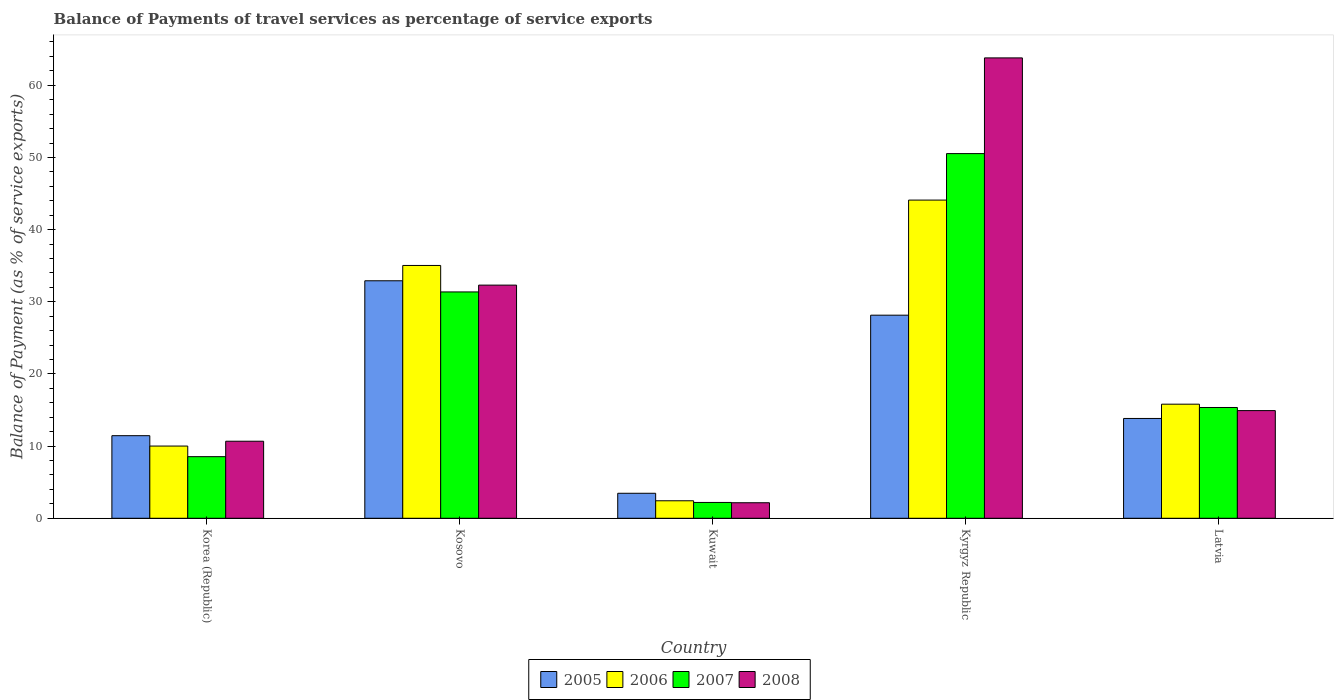How many different coloured bars are there?
Your answer should be compact. 4. How many bars are there on the 1st tick from the left?
Your response must be concise. 4. How many bars are there on the 2nd tick from the right?
Keep it short and to the point. 4. What is the label of the 4th group of bars from the left?
Give a very brief answer. Kyrgyz Republic. What is the balance of payments of travel services in 2005 in Kuwait?
Ensure brevity in your answer.  3.46. Across all countries, what is the maximum balance of payments of travel services in 2005?
Offer a very short reply. 32.91. Across all countries, what is the minimum balance of payments of travel services in 2008?
Give a very brief answer. 2.15. In which country was the balance of payments of travel services in 2007 maximum?
Offer a very short reply. Kyrgyz Republic. In which country was the balance of payments of travel services in 2007 minimum?
Your response must be concise. Kuwait. What is the total balance of payments of travel services in 2007 in the graph?
Offer a very short reply. 107.97. What is the difference between the balance of payments of travel services in 2006 in Korea (Republic) and that in Kuwait?
Offer a very short reply. 7.58. What is the difference between the balance of payments of travel services in 2007 in Kosovo and the balance of payments of travel services in 2005 in Korea (Republic)?
Offer a terse response. 19.92. What is the average balance of payments of travel services in 2007 per country?
Your answer should be compact. 21.59. What is the difference between the balance of payments of travel services of/in 2005 and balance of payments of travel services of/in 2007 in Kuwait?
Your response must be concise. 1.27. In how many countries, is the balance of payments of travel services in 2006 greater than 16 %?
Ensure brevity in your answer.  2. What is the ratio of the balance of payments of travel services in 2007 in Korea (Republic) to that in Latvia?
Ensure brevity in your answer.  0.56. What is the difference between the highest and the second highest balance of payments of travel services in 2005?
Your answer should be very brief. 4.77. What is the difference between the highest and the lowest balance of payments of travel services in 2005?
Ensure brevity in your answer.  29.45. In how many countries, is the balance of payments of travel services in 2006 greater than the average balance of payments of travel services in 2006 taken over all countries?
Your answer should be compact. 2. Is the sum of the balance of payments of travel services in 2007 in Korea (Republic) and Latvia greater than the maximum balance of payments of travel services in 2005 across all countries?
Ensure brevity in your answer.  No. What does the 4th bar from the left in Kuwait represents?
Ensure brevity in your answer.  2008. What does the 1st bar from the right in Kosovo represents?
Your answer should be compact. 2008. Is it the case that in every country, the sum of the balance of payments of travel services in 2005 and balance of payments of travel services in 2008 is greater than the balance of payments of travel services in 2006?
Provide a short and direct response. Yes. How many bars are there?
Your response must be concise. 20. What is the difference between two consecutive major ticks on the Y-axis?
Offer a very short reply. 10. Does the graph contain any zero values?
Offer a very short reply. No. How are the legend labels stacked?
Ensure brevity in your answer.  Horizontal. What is the title of the graph?
Give a very brief answer. Balance of Payments of travel services as percentage of service exports. What is the label or title of the Y-axis?
Ensure brevity in your answer.  Balance of Payment (as % of service exports). What is the Balance of Payment (as % of service exports) of 2005 in Korea (Republic)?
Provide a succinct answer. 11.44. What is the Balance of Payment (as % of service exports) in 2006 in Korea (Republic)?
Give a very brief answer. 10.01. What is the Balance of Payment (as % of service exports) of 2007 in Korea (Republic)?
Provide a short and direct response. 8.54. What is the Balance of Payment (as % of service exports) in 2008 in Korea (Republic)?
Ensure brevity in your answer.  10.68. What is the Balance of Payment (as % of service exports) in 2005 in Kosovo?
Give a very brief answer. 32.91. What is the Balance of Payment (as % of service exports) in 2006 in Kosovo?
Keep it short and to the point. 35.03. What is the Balance of Payment (as % of service exports) in 2007 in Kosovo?
Provide a succinct answer. 31.36. What is the Balance of Payment (as % of service exports) in 2008 in Kosovo?
Offer a terse response. 32.31. What is the Balance of Payment (as % of service exports) in 2005 in Kuwait?
Give a very brief answer. 3.46. What is the Balance of Payment (as % of service exports) of 2006 in Kuwait?
Offer a terse response. 2.42. What is the Balance of Payment (as % of service exports) of 2007 in Kuwait?
Your response must be concise. 2.19. What is the Balance of Payment (as % of service exports) of 2008 in Kuwait?
Make the answer very short. 2.15. What is the Balance of Payment (as % of service exports) in 2005 in Kyrgyz Republic?
Offer a terse response. 28.14. What is the Balance of Payment (as % of service exports) of 2006 in Kyrgyz Republic?
Make the answer very short. 44.09. What is the Balance of Payment (as % of service exports) in 2007 in Kyrgyz Republic?
Your answer should be very brief. 50.53. What is the Balance of Payment (as % of service exports) of 2008 in Kyrgyz Republic?
Keep it short and to the point. 63.79. What is the Balance of Payment (as % of service exports) in 2005 in Latvia?
Make the answer very short. 13.83. What is the Balance of Payment (as % of service exports) of 2006 in Latvia?
Make the answer very short. 15.81. What is the Balance of Payment (as % of service exports) of 2007 in Latvia?
Keep it short and to the point. 15.35. What is the Balance of Payment (as % of service exports) in 2008 in Latvia?
Make the answer very short. 14.92. Across all countries, what is the maximum Balance of Payment (as % of service exports) in 2005?
Keep it short and to the point. 32.91. Across all countries, what is the maximum Balance of Payment (as % of service exports) of 2006?
Give a very brief answer. 44.09. Across all countries, what is the maximum Balance of Payment (as % of service exports) in 2007?
Offer a terse response. 50.53. Across all countries, what is the maximum Balance of Payment (as % of service exports) of 2008?
Your answer should be very brief. 63.79. Across all countries, what is the minimum Balance of Payment (as % of service exports) in 2005?
Offer a terse response. 3.46. Across all countries, what is the minimum Balance of Payment (as % of service exports) in 2006?
Provide a succinct answer. 2.42. Across all countries, what is the minimum Balance of Payment (as % of service exports) of 2007?
Offer a terse response. 2.19. Across all countries, what is the minimum Balance of Payment (as % of service exports) in 2008?
Ensure brevity in your answer.  2.15. What is the total Balance of Payment (as % of service exports) of 2005 in the graph?
Provide a short and direct response. 89.79. What is the total Balance of Payment (as % of service exports) in 2006 in the graph?
Keep it short and to the point. 107.36. What is the total Balance of Payment (as % of service exports) in 2007 in the graph?
Offer a very short reply. 107.97. What is the total Balance of Payment (as % of service exports) of 2008 in the graph?
Ensure brevity in your answer.  123.85. What is the difference between the Balance of Payment (as % of service exports) of 2005 in Korea (Republic) and that in Kosovo?
Make the answer very short. -21.47. What is the difference between the Balance of Payment (as % of service exports) of 2006 in Korea (Republic) and that in Kosovo?
Ensure brevity in your answer.  -25.03. What is the difference between the Balance of Payment (as % of service exports) in 2007 in Korea (Republic) and that in Kosovo?
Ensure brevity in your answer.  -22.83. What is the difference between the Balance of Payment (as % of service exports) in 2008 in Korea (Republic) and that in Kosovo?
Provide a succinct answer. -21.63. What is the difference between the Balance of Payment (as % of service exports) in 2005 in Korea (Republic) and that in Kuwait?
Offer a terse response. 7.98. What is the difference between the Balance of Payment (as % of service exports) of 2006 in Korea (Republic) and that in Kuwait?
Give a very brief answer. 7.58. What is the difference between the Balance of Payment (as % of service exports) in 2007 in Korea (Republic) and that in Kuwait?
Ensure brevity in your answer.  6.34. What is the difference between the Balance of Payment (as % of service exports) in 2008 in Korea (Republic) and that in Kuwait?
Offer a very short reply. 8.52. What is the difference between the Balance of Payment (as % of service exports) in 2005 in Korea (Republic) and that in Kyrgyz Republic?
Ensure brevity in your answer.  -16.7. What is the difference between the Balance of Payment (as % of service exports) of 2006 in Korea (Republic) and that in Kyrgyz Republic?
Provide a short and direct response. -34.08. What is the difference between the Balance of Payment (as % of service exports) of 2007 in Korea (Republic) and that in Kyrgyz Republic?
Ensure brevity in your answer.  -41.99. What is the difference between the Balance of Payment (as % of service exports) in 2008 in Korea (Republic) and that in Kyrgyz Republic?
Offer a terse response. -53.12. What is the difference between the Balance of Payment (as % of service exports) of 2005 in Korea (Republic) and that in Latvia?
Your answer should be very brief. -2.39. What is the difference between the Balance of Payment (as % of service exports) of 2006 in Korea (Republic) and that in Latvia?
Offer a terse response. -5.8. What is the difference between the Balance of Payment (as % of service exports) in 2007 in Korea (Republic) and that in Latvia?
Offer a terse response. -6.81. What is the difference between the Balance of Payment (as % of service exports) in 2008 in Korea (Republic) and that in Latvia?
Provide a short and direct response. -4.24. What is the difference between the Balance of Payment (as % of service exports) of 2005 in Kosovo and that in Kuwait?
Give a very brief answer. 29.45. What is the difference between the Balance of Payment (as % of service exports) of 2006 in Kosovo and that in Kuwait?
Your answer should be compact. 32.61. What is the difference between the Balance of Payment (as % of service exports) in 2007 in Kosovo and that in Kuwait?
Give a very brief answer. 29.17. What is the difference between the Balance of Payment (as % of service exports) of 2008 in Kosovo and that in Kuwait?
Keep it short and to the point. 30.16. What is the difference between the Balance of Payment (as % of service exports) in 2005 in Kosovo and that in Kyrgyz Republic?
Offer a terse response. 4.77. What is the difference between the Balance of Payment (as % of service exports) in 2006 in Kosovo and that in Kyrgyz Republic?
Provide a short and direct response. -9.06. What is the difference between the Balance of Payment (as % of service exports) in 2007 in Kosovo and that in Kyrgyz Republic?
Make the answer very short. -19.17. What is the difference between the Balance of Payment (as % of service exports) of 2008 in Kosovo and that in Kyrgyz Republic?
Keep it short and to the point. -31.49. What is the difference between the Balance of Payment (as % of service exports) of 2005 in Kosovo and that in Latvia?
Give a very brief answer. 19.08. What is the difference between the Balance of Payment (as % of service exports) of 2006 in Kosovo and that in Latvia?
Your response must be concise. 19.22. What is the difference between the Balance of Payment (as % of service exports) of 2007 in Kosovo and that in Latvia?
Offer a very short reply. 16.01. What is the difference between the Balance of Payment (as % of service exports) in 2008 in Kosovo and that in Latvia?
Your response must be concise. 17.39. What is the difference between the Balance of Payment (as % of service exports) of 2005 in Kuwait and that in Kyrgyz Republic?
Your answer should be very brief. -24.68. What is the difference between the Balance of Payment (as % of service exports) of 2006 in Kuwait and that in Kyrgyz Republic?
Your answer should be compact. -41.67. What is the difference between the Balance of Payment (as % of service exports) of 2007 in Kuwait and that in Kyrgyz Republic?
Your answer should be very brief. -48.34. What is the difference between the Balance of Payment (as % of service exports) of 2008 in Kuwait and that in Kyrgyz Republic?
Ensure brevity in your answer.  -61.64. What is the difference between the Balance of Payment (as % of service exports) in 2005 in Kuwait and that in Latvia?
Make the answer very short. -10.37. What is the difference between the Balance of Payment (as % of service exports) of 2006 in Kuwait and that in Latvia?
Offer a very short reply. -13.39. What is the difference between the Balance of Payment (as % of service exports) in 2007 in Kuwait and that in Latvia?
Your answer should be very brief. -13.16. What is the difference between the Balance of Payment (as % of service exports) in 2008 in Kuwait and that in Latvia?
Your answer should be compact. -12.77. What is the difference between the Balance of Payment (as % of service exports) of 2005 in Kyrgyz Republic and that in Latvia?
Give a very brief answer. 14.31. What is the difference between the Balance of Payment (as % of service exports) in 2006 in Kyrgyz Republic and that in Latvia?
Offer a very short reply. 28.28. What is the difference between the Balance of Payment (as % of service exports) in 2007 in Kyrgyz Republic and that in Latvia?
Your answer should be very brief. 35.18. What is the difference between the Balance of Payment (as % of service exports) of 2008 in Kyrgyz Republic and that in Latvia?
Your response must be concise. 48.87. What is the difference between the Balance of Payment (as % of service exports) of 2005 in Korea (Republic) and the Balance of Payment (as % of service exports) of 2006 in Kosovo?
Your answer should be compact. -23.59. What is the difference between the Balance of Payment (as % of service exports) of 2005 in Korea (Republic) and the Balance of Payment (as % of service exports) of 2007 in Kosovo?
Your answer should be compact. -19.92. What is the difference between the Balance of Payment (as % of service exports) of 2005 in Korea (Republic) and the Balance of Payment (as % of service exports) of 2008 in Kosovo?
Keep it short and to the point. -20.86. What is the difference between the Balance of Payment (as % of service exports) in 2006 in Korea (Republic) and the Balance of Payment (as % of service exports) in 2007 in Kosovo?
Keep it short and to the point. -21.36. What is the difference between the Balance of Payment (as % of service exports) in 2006 in Korea (Republic) and the Balance of Payment (as % of service exports) in 2008 in Kosovo?
Offer a terse response. -22.3. What is the difference between the Balance of Payment (as % of service exports) in 2007 in Korea (Republic) and the Balance of Payment (as % of service exports) in 2008 in Kosovo?
Keep it short and to the point. -23.77. What is the difference between the Balance of Payment (as % of service exports) of 2005 in Korea (Republic) and the Balance of Payment (as % of service exports) of 2006 in Kuwait?
Make the answer very short. 9.02. What is the difference between the Balance of Payment (as % of service exports) in 2005 in Korea (Republic) and the Balance of Payment (as % of service exports) in 2007 in Kuwait?
Keep it short and to the point. 9.25. What is the difference between the Balance of Payment (as % of service exports) of 2005 in Korea (Republic) and the Balance of Payment (as % of service exports) of 2008 in Kuwait?
Ensure brevity in your answer.  9.29. What is the difference between the Balance of Payment (as % of service exports) of 2006 in Korea (Republic) and the Balance of Payment (as % of service exports) of 2007 in Kuwait?
Make the answer very short. 7.81. What is the difference between the Balance of Payment (as % of service exports) of 2006 in Korea (Republic) and the Balance of Payment (as % of service exports) of 2008 in Kuwait?
Your response must be concise. 7.85. What is the difference between the Balance of Payment (as % of service exports) in 2007 in Korea (Republic) and the Balance of Payment (as % of service exports) in 2008 in Kuwait?
Provide a succinct answer. 6.38. What is the difference between the Balance of Payment (as % of service exports) of 2005 in Korea (Republic) and the Balance of Payment (as % of service exports) of 2006 in Kyrgyz Republic?
Provide a short and direct response. -32.65. What is the difference between the Balance of Payment (as % of service exports) of 2005 in Korea (Republic) and the Balance of Payment (as % of service exports) of 2007 in Kyrgyz Republic?
Your answer should be very brief. -39.09. What is the difference between the Balance of Payment (as % of service exports) in 2005 in Korea (Republic) and the Balance of Payment (as % of service exports) in 2008 in Kyrgyz Republic?
Your answer should be very brief. -52.35. What is the difference between the Balance of Payment (as % of service exports) in 2006 in Korea (Republic) and the Balance of Payment (as % of service exports) in 2007 in Kyrgyz Republic?
Ensure brevity in your answer.  -40.52. What is the difference between the Balance of Payment (as % of service exports) in 2006 in Korea (Republic) and the Balance of Payment (as % of service exports) in 2008 in Kyrgyz Republic?
Your response must be concise. -53.79. What is the difference between the Balance of Payment (as % of service exports) in 2007 in Korea (Republic) and the Balance of Payment (as % of service exports) in 2008 in Kyrgyz Republic?
Keep it short and to the point. -55.26. What is the difference between the Balance of Payment (as % of service exports) of 2005 in Korea (Republic) and the Balance of Payment (as % of service exports) of 2006 in Latvia?
Your answer should be very brief. -4.37. What is the difference between the Balance of Payment (as % of service exports) of 2005 in Korea (Republic) and the Balance of Payment (as % of service exports) of 2007 in Latvia?
Offer a very short reply. -3.91. What is the difference between the Balance of Payment (as % of service exports) of 2005 in Korea (Republic) and the Balance of Payment (as % of service exports) of 2008 in Latvia?
Offer a very short reply. -3.48. What is the difference between the Balance of Payment (as % of service exports) in 2006 in Korea (Republic) and the Balance of Payment (as % of service exports) in 2007 in Latvia?
Ensure brevity in your answer.  -5.34. What is the difference between the Balance of Payment (as % of service exports) of 2006 in Korea (Republic) and the Balance of Payment (as % of service exports) of 2008 in Latvia?
Your response must be concise. -4.91. What is the difference between the Balance of Payment (as % of service exports) in 2007 in Korea (Republic) and the Balance of Payment (as % of service exports) in 2008 in Latvia?
Make the answer very short. -6.38. What is the difference between the Balance of Payment (as % of service exports) of 2005 in Kosovo and the Balance of Payment (as % of service exports) of 2006 in Kuwait?
Your response must be concise. 30.49. What is the difference between the Balance of Payment (as % of service exports) in 2005 in Kosovo and the Balance of Payment (as % of service exports) in 2007 in Kuwait?
Offer a very short reply. 30.72. What is the difference between the Balance of Payment (as % of service exports) in 2005 in Kosovo and the Balance of Payment (as % of service exports) in 2008 in Kuwait?
Offer a very short reply. 30.76. What is the difference between the Balance of Payment (as % of service exports) of 2006 in Kosovo and the Balance of Payment (as % of service exports) of 2007 in Kuwait?
Offer a terse response. 32.84. What is the difference between the Balance of Payment (as % of service exports) of 2006 in Kosovo and the Balance of Payment (as % of service exports) of 2008 in Kuwait?
Your response must be concise. 32.88. What is the difference between the Balance of Payment (as % of service exports) in 2007 in Kosovo and the Balance of Payment (as % of service exports) in 2008 in Kuwait?
Make the answer very short. 29.21. What is the difference between the Balance of Payment (as % of service exports) in 2005 in Kosovo and the Balance of Payment (as % of service exports) in 2006 in Kyrgyz Republic?
Make the answer very short. -11.18. What is the difference between the Balance of Payment (as % of service exports) in 2005 in Kosovo and the Balance of Payment (as % of service exports) in 2007 in Kyrgyz Republic?
Offer a terse response. -17.62. What is the difference between the Balance of Payment (as % of service exports) of 2005 in Kosovo and the Balance of Payment (as % of service exports) of 2008 in Kyrgyz Republic?
Keep it short and to the point. -30.88. What is the difference between the Balance of Payment (as % of service exports) in 2006 in Kosovo and the Balance of Payment (as % of service exports) in 2007 in Kyrgyz Republic?
Offer a very short reply. -15.5. What is the difference between the Balance of Payment (as % of service exports) in 2006 in Kosovo and the Balance of Payment (as % of service exports) in 2008 in Kyrgyz Republic?
Provide a short and direct response. -28.76. What is the difference between the Balance of Payment (as % of service exports) of 2007 in Kosovo and the Balance of Payment (as % of service exports) of 2008 in Kyrgyz Republic?
Offer a terse response. -32.43. What is the difference between the Balance of Payment (as % of service exports) of 2005 in Kosovo and the Balance of Payment (as % of service exports) of 2006 in Latvia?
Keep it short and to the point. 17.1. What is the difference between the Balance of Payment (as % of service exports) of 2005 in Kosovo and the Balance of Payment (as % of service exports) of 2007 in Latvia?
Ensure brevity in your answer.  17.56. What is the difference between the Balance of Payment (as % of service exports) in 2005 in Kosovo and the Balance of Payment (as % of service exports) in 2008 in Latvia?
Your response must be concise. 17.99. What is the difference between the Balance of Payment (as % of service exports) in 2006 in Kosovo and the Balance of Payment (as % of service exports) in 2007 in Latvia?
Your response must be concise. 19.68. What is the difference between the Balance of Payment (as % of service exports) of 2006 in Kosovo and the Balance of Payment (as % of service exports) of 2008 in Latvia?
Ensure brevity in your answer.  20.11. What is the difference between the Balance of Payment (as % of service exports) of 2007 in Kosovo and the Balance of Payment (as % of service exports) of 2008 in Latvia?
Ensure brevity in your answer.  16.44. What is the difference between the Balance of Payment (as % of service exports) in 2005 in Kuwait and the Balance of Payment (as % of service exports) in 2006 in Kyrgyz Republic?
Your answer should be very brief. -40.63. What is the difference between the Balance of Payment (as % of service exports) of 2005 in Kuwait and the Balance of Payment (as % of service exports) of 2007 in Kyrgyz Republic?
Ensure brevity in your answer.  -47.07. What is the difference between the Balance of Payment (as % of service exports) of 2005 in Kuwait and the Balance of Payment (as % of service exports) of 2008 in Kyrgyz Republic?
Offer a terse response. -60.33. What is the difference between the Balance of Payment (as % of service exports) of 2006 in Kuwait and the Balance of Payment (as % of service exports) of 2007 in Kyrgyz Republic?
Provide a short and direct response. -48.11. What is the difference between the Balance of Payment (as % of service exports) of 2006 in Kuwait and the Balance of Payment (as % of service exports) of 2008 in Kyrgyz Republic?
Keep it short and to the point. -61.37. What is the difference between the Balance of Payment (as % of service exports) in 2007 in Kuwait and the Balance of Payment (as % of service exports) in 2008 in Kyrgyz Republic?
Give a very brief answer. -61.6. What is the difference between the Balance of Payment (as % of service exports) of 2005 in Kuwait and the Balance of Payment (as % of service exports) of 2006 in Latvia?
Offer a terse response. -12.35. What is the difference between the Balance of Payment (as % of service exports) in 2005 in Kuwait and the Balance of Payment (as % of service exports) in 2007 in Latvia?
Your answer should be very brief. -11.89. What is the difference between the Balance of Payment (as % of service exports) in 2005 in Kuwait and the Balance of Payment (as % of service exports) in 2008 in Latvia?
Your answer should be very brief. -11.46. What is the difference between the Balance of Payment (as % of service exports) of 2006 in Kuwait and the Balance of Payment (as % of service exports) of 2007 in Latvia?
Give a very brief answer. -12.93. What is the difference between the Balance of Payment (as % of service exports) of 2006 in Kuwait and the Balance of Payment (as % of service exports) of 2008 in Latvia?
Make the answer very short. -12.5. What is the difference between the Balance of Payment (as % of service exports) in 2007 in Kuwait and the Balance of Payment (as % of service exports) in 2008 in Latvia?
Your response must be concise. -12.73. What is the difference between the Balance of Payment (as % of service exports) of 2005 in Kyrgyz Republic and the Balance of Payment (as % of service exports) of 2006 in Latvia?
Provide a succinct answer. 12.33. What is the difference between the Balance of Payment (as % of service exports) of 2005 in Kyrgyz Republic and the Balance of Payment (as % of service exports) of 2007 in Latvia?
Keep it short and to the point. 12.79. What is the difference between the Balance of Payment (as % of service exports) in 2005 in Kyrgyz Republic and the Balance of Payment (as % of service exports) in 2008 in Latvia?
Your response must be concise. 13.22. What is the difference between the Balance of Payment (as % of service exports) in 2006 in Kyrgyz Republic and the Balance of Payment (as % of service exports) in 2007 in Latvia?
Ensure brevity in your answer.  28.74. What is the difference between the Balance of Payment (as % of service exports) in 2006 in Kyrgyz Republic and the Balance of Payment (as % of service exports) in 2008 in Latvia?
Ensure brevity in your answer.  29.17. What is the difference between the Balance of Payment (as % of service exports) of 2007 in Kyrgyz Republic and the Balance of Payment (as % of service exports) of 2008 in Latvia?
Keep it short and to the point. 35.61. What is the average Balance of Payment (as % of service exports) of 2005 per country?
Offer a very short reply. 17.96. What is the average Balance of Payment (as % of service exports) in 2006 per country?
Your response must be concise. 21.47. What is the average Balance of Payment (as % of service exports) in 2007 per country?
Give a very brief answer. 21.59. What is the average Balance of Payment (as % of service exports) in 2008 per country?
Your response must be concise. 24.77. What is the difference between the Balance of Payment (as % of service exports) of 2005 and Balance of Payment (as % of service exports) of 2006 in Korea (Republic)?
Give a very brief answer. 1.44. What is the difference between the Balance of Payment (as % of service exports) of 2005 and Balance of Payment (as % of service exports) of 2007 in Korea (Republic)?
Make the answer very short. 2.91. What is the difference between the Balance of Payment (as % of service exports) of 2005 and Balance of Payment (as % of service exports) of 2008 in Korea (Republic)?
Provide a short and direct response. 0.77. What is the difference between the Balance of Payment (as % of service exports) in 2006 and Balance of Payment (as % of service exports) in 2007 in Korea (Republic)?
Make the answer very short. 1.47. What is the difference between the Balance of Payment (as % of service exports) in 2006 and Balance of Payment (as % of service exports) in 2008 in Korea (Republic)?
Offer a terse response. -0.67. What is the difference between the Balance of Payment (as % of service exports) in 2007 and Balance of Payment (as % of service exports) in 2008 in Korea (Republic)?
Keep it short and to the point. -2.14. What is the difference between the Balance of Payment (as % of service exports) in 2005 and Balance of Payment (as % of service exports) in 2006 in Kosovo?
Your answer should be very brief. -2.12. What is the difference between the Balance of Payment (as % of service exports) in 2005 and Balance of Payment (as % of service exports) in 2007 in Kosovo?
Your answer should be compact. 1.55. What is the difference between the Balance of Payment (as % of service exports) of 2005 and Balance of Payment (as % of service exports) of 2008 in Kosovo?
Offer a terse response. 0.6. What is the difference between the Balance of Payment (as % of service exports) of 2006 and Balance of Payment (as % of service exports) of 2007 in Kosovo?
Make the answer very short. 3.67. What is the difference between the Balance of Payment (as % of service exports) in 2006 and Balance of Payment (as % of service exports) in 2008 in Kosovo?
Your answer should be compact. 2.72. What is the difference between the Balance of Payment (as % of service exports) of 2007 and Balance of Payment (as % of service exports) of 2008 in Kosovo?
Give a very brief answer. -0.94. What is the difference between the Balance of Payment (as % of service exports) in 2005 and Balance of Payment (as % of service exports) in 2006 in Kuwait?
Offer a terse response. 1.04. What is the difference between the Balance of Payment (as % of service exports) in 2005 and Balance of Payment (as % of service exports) in 2007 in Kuwait?
Your answer should be compact. 1.27. What is the difference between the Balance of Payment (as % of service exports) of 2005 and Balance of Payment (as % of service exports) of 2008 in Kuwait?
Your answer should be compact. 1.31. What is the difference between the Balance of Payment (as % of service exports) in 2006 and Balance of Payment (as % of service exports) in 2007 in Kuwait?
Give a very brief answer. 0.23. What is the difference between the Balance of Payment (as % of service exports) of 2006 and Balance of Payment (as % of service exports) of 2008 in Kuwait?
Provide a succinct answer. 0.27. What is the difference between the Balance of Payment (as % of service exports) of 2007 and Balance of Payment (as % of service exports) of 2008 in Kuwait?
Make the answer very short. 0.04. What is the difference between the Balance of Payment (as % of service exports) of 2005 and Balance of Payment (as % of service exports) of 2006 in Kyrgyz Republic?
Your answer should be compact. -15.95. What is the difference between the Balance of Payment (as % of service exports) of 2005 and Balance of Payment (as % of service exports) of 2007 in Kyrgyz Republic?
Ensure brevity in your answer.  -22.39. What is the difference between the Balance of Payment (as % of service exports) of 2005 and Balance of Payment (as % of service exports) of 2008 in Kyrgyz Republic?
Offer a terse response. -35.65. What is the difference between the Balance of Payment (as % of service exports) in 2006 and Balance of Payment (as % of service exports) in 2007 in Kyrgyz Republic?
Make the answer very short. -6.44. What is the difference between the Balance of Payment (as % of service exports) of 2006 and Balance of Payment (as % of service exports) of 2008 in Kyrgyz Republic?
Your answer should be compact. -19.7. What is the difference between the Balance of Payment (as % of service exports) of 2007 and Balance of Payment (as % of service exports) of 2008 in Kyrgyz Republic?
Your answer should be compact. -13.26. What is the difference between the Balance of Payment (as % of service exports) of 2005 and Balance of Payment (as % of service exports) of 2006 in Latvia?
Ensure brevity in your answer.  -1.98. What is the difference between the Balance of Payment (as % of service exports) in 2005 and Balance of Payment (as % of service exports) in 2007 in Latvia?
Give a very brief answer. -1.52. What is the difference between the Balance of Payment (as % of service exports) of 2005 and Balance of Payment (as % of service exports) of 2008 in Latvia?
Offer a terse response. -1.09. What is the difference between the Balance of Payment (as % of service exports) in 2006 and Balance of Payment (as % of service exports) in 2007 in Latvia?
Make the answer very short. 0.46. What is the difference between the Balance of Payment (as % of service exports) in 2006 and Balance of Payment (as % of service exports) in 2008 in Latvia?
Ensure brevity in your answer.  0.89. What is the difference between the Balance of Payment (as % of service exports) in 2007 and Balance of Payment (as % of service exports) in 2008 in Latvia?
Give a very brief answer. 0.43. What is the ratio of the Balance of Payment (as % of service exports) of 2005 in Korea (Republic) to that in Kosovo?
Make the answer very short. 0.35. What is the ratio of the Balance of Payment (as % of service exports) of 2006 in Korea (Republic) to that in Kosovo?
Your answer should be very brief. 0.29. What is the ratio of the Balance of Payment (as % of service exports) of 2007 in Korea (Republic) to that in Kosovo?
Make the answer very short. 0.27. What is the ratio of the Balance of Payment (as % of service exports) in 2008 in Korea (Republic) to that in Kosovo?
Your answer should be compact. 0.33. What is the ratio of the Balance of Payment (as % of service exports) in 2005 in Korea (Republic) to that in Kuwait?
Your answer should be compact. 3.3. What is the ratio of the Balance of Payment (as % of service exports) of 2006 in Korea (Republic) to that in Kuwait?
Your response must be concise. 4.13. What is the ratio of the Balance of Payment (as % of service exports) in 2007 in Korea (Republic) to that in Kuwait?
Provide a short and direct response. 3.89. What is the ratio of the Balance of Payment (as % of service exports) in 2008 in Korea (Republic) to that in Kuwait?
Your answer should be compact. 4.96. What is the ratio of the Balance of Payment (as % of service exports) of 2005 in Korea (Republic) to that in Kyrgyz Republic?
Offer a terse response. 0.41. What is the ratio of the Balance of Payment (as % of service exports) of 2006 in Korea (Republic) to that in Kyrgyz Republic?
Provide a short and direct response. 0.23. What is the ratio of the Balance of Payment (as % of service exports) of 2007 in Korea (Republic) to that in Kyrgyz Republic?
Provide a short and direct response. 0.17. What is the ratio of the Balance of Payment (as % of service exports) in 2008 in Korea (Republic) to that in Kyrgyz Republic?
Provide a short and direct response. 0.17. What is the ratio of the Balance of Payment (as % of service exports) of 2005 in Korea (Republic) to that in Latvia?
Your answer should be compact. 0.83. What is the ratio of the Balance of Payment (as % of service exports) of 2006 in Korea (Republic) to that in Latvia?
Offer a terse response. 0.63. What is the ratio of the Balance of Payment (as % of service exports) in 2007 in Korea (Republic) to that in Latvia?
Give a very brief answer. 0.56. What is the ratio of the Balance of Payment (as % of service exports) in 2008 in Korea (Republic) to that in Latvia?
Offer a very short reply. 0.72. What is the ratio of the Balance of Payment (as % of service exports) of 2005 in Kosovo to that in Kuwait?
Make the answer very short. 9.5. What is the ratio of the Balance of Payment (as % of service exports) in 2006 in Kosovo to that in Kuwait?
Provide a succinct answer. 14.45. What is the ratio of the Balance of Payment (as % of service exports) in 2007 in Kosovo to that in Kuwait?
Provide a succinct answer. 14.3. What is the ratio of the Balance of Payment (as % of service exports) of 2008 in Kosovo to that in Kuwait?
Ensure brevity in your answer.  15.01. What is the ratio of the Balance of Payment (as % of service exports) in 2005 in Kosovo to that in Kyrgyz Republic?
Give a very brief answer. 1.17. What is the ratio of the Balance of Payment (as % of service exports) in 2006 in Kosovo to that in Kyrgyz Republic?
Give a very brief answer. 0.79. What is the ratio of the Balance of Payment (as % of service exports) in 2007 in Kosovo to that in Kyrgyz Republic?
Provide a succinct answer. 0.62. What is the ratio of the Balance of Payment (as % of service exports) of 2008 in Kosovo to that in Kyrgyz Republic?
Your answer should be very brief. 0.51. What is the ratio of the Balance of Payment (as % of service exports) in 2005 in Kosovo to that in Latvia?
Offer a terse response. 2.38. What is the ratio of the Balance of Payment (as % of service exports) of 2006 in Kosovo to that in Latvia?
Ensure brevity in your answer.  2.22. What is the ratio of the Balance of Payment (as % of service exports) in 2007 in Kosovo to that in Latvia?
Offer a terse response. 2.04. What is the ratio of the Balance of Payment (as % of service exports) in 2008 in Kosovo to that in Latvia?
Offer a terse response. 2.17. What is the ratio of the Balance of Payment (as % of service exports) of 2005 in Kuwait to that in Kyrgyz Republic?
Keep it short and to the point. 0.12. What is the ratio of the Balance of Payment (as % of service exports) of 2006 in Kuwait to that in Kyrgyz Republic?
Your answer should be very brief. 0.06. What is the ratio of the Balance of Payment (as % of service exports) in 2007 in Kuwait to that in Kyrgyz Republic?
Your answer should be very brief. 0.04. What is the ratio of the Balance of Payment (as % of service exports) of 2008 in Kuwait to that in Kyrgyz Republic?
Your response must be concise. 0.03. What is the ratio of the Balance of Payment (as % of service exports) in 2005 in Kuwait to that in Latvia?
Offer a terse response. 0.25. What is the ratio of the Balance of Payment (as % of service exports) of 2006 in Kuwait to that in Latvia?
Your answer should be compact. 0.15. What is the ratio of the Balance of Payment (as % of service exports) in 2007 in Kuwait to that in Latvia?
Provide a succinct answer. 0.14. What is the ratio of the Balance of Payment (as % of service exports) of 2008 in Kuwait to that in Latvia?
Provide a succinct answer. 0.14. What is the ratio of the Balance of Payment (as % of service exports) in 2005 in Kyrgyz Republic to that in Latvia?
Provide a short and direct response. 2.03. What is the ratio of the Balance of Payment (as % of service exports) of 2006 in Kyrgyz Republic to that in Latvia?
Keep it short and to the point. 2.79. What is the ratio of the Balance of Payment (as % of service exports) of 2007 in Kyrgyz Republic to that in Latvia?
Your answer should be very brief. 3.29. What is the ratio of the Balance of Payment (as % of service exports) of 2008 in Kyrgyz Republic to that in Latvia?
Make the answer very short. 4.28. What is the difference between the highest and the second highest Balance of Payment (as % of service exports) of 2005?
Keep it short and to the point. 4.77. What is the difference between the highest and the second highest Balance of Payment (as % of service exports) of 2006?
Offer a very short reply. 9.06. What is the difference between the highest and the second highest Balance of Payment (as % of service exports) in 2007?
Keep it short and to the point. 19.17. What is the difference between the highest and the second highest Balance of Payment (as % of service exports) in 2008?
Your response must be concise. 31.49. What is the difference between the highest and the lowest Balance of Payment (as % of service exports) in 2005?
Keep it short and to the point. 29.45. What is the difference between the highest and the lowest Balance of Payment (as % of service exports) in 2006?
Make the answer very short. 41.67. What is the difference between the highest and the lowest Balance of Payment (as % of service exports) of 2007?
Provide a succinct answer. 48.34. What is the difference between the highest and the lowest Balance of Payment (as % of service exports) of 2008?
Provide a short and direct response. 61.64. 